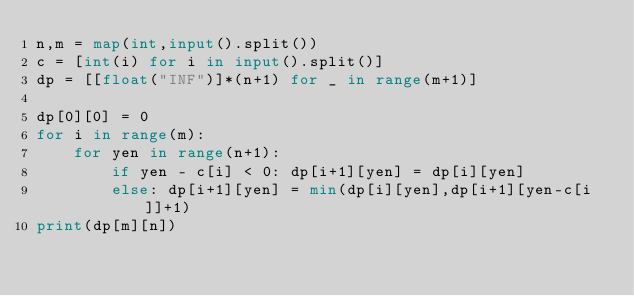<code> <loc_0><loc_0><loc_500><loc_500><_Python_>n,m = map(int,input().split())
c = [int(i) for i in input().split()]
dp = [[float("INF")]*(n+1) for _ in range(m+1)]

dp[0][0] = 0
for i in range(m):
    for yen in range(n+1):
        if yen - c[i] < 0: dp[i+1][yen] = dp[i][yen]
        else: dp[i+1][yen] = min(dp[i][yen],dp[i+1][yen-c[i]]+1)
print(dp[m][n])
</code> 